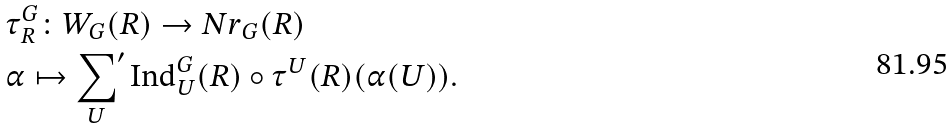Convert formula to latex. <formula><loc_0><loc_0><loc_500><loc_500>& \tau _ { R } ^ { G } \colon W _ { G } ( R ) \to { N r } _ { G } ( R ) \\ & \alpha \mapsto { \underset { U } { \sum } ^ { \prime } } \, \text {Ind} _ { U } ^ { G } ( R ) \circ \tau ^ { U } ( R ) ( \alpha ( U ) ) .</formula> 